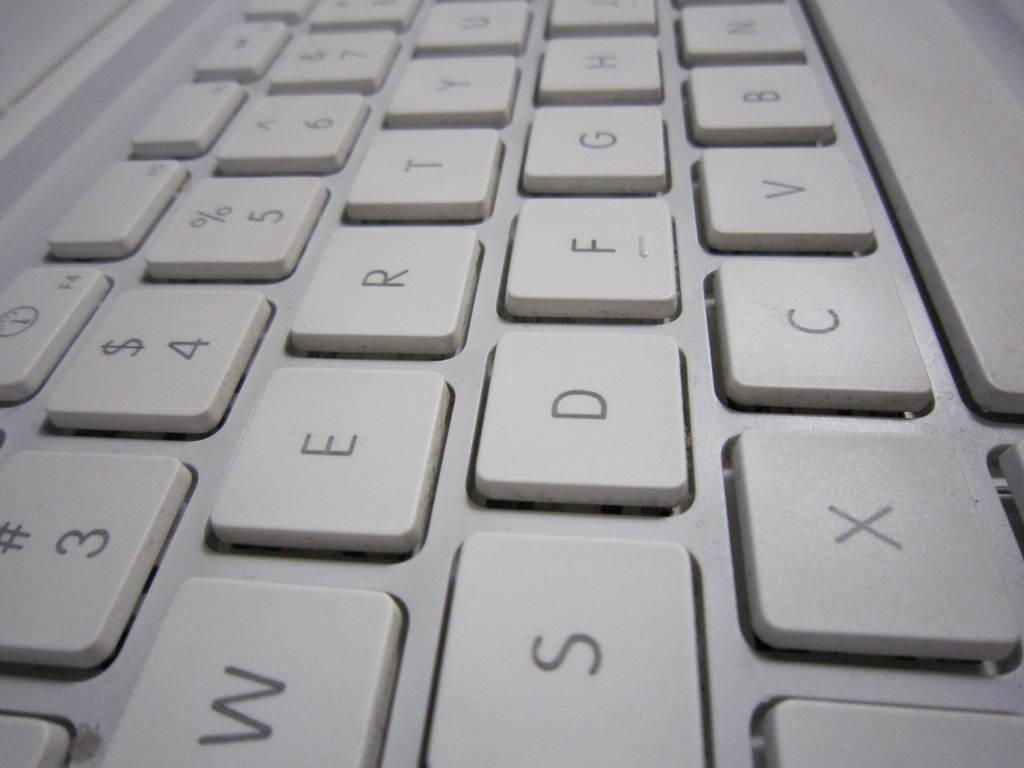Which number key is below 4?
Ensure brevity in your answer.  3. What key is to the left of the "c" key?
Provide a short and direct response. X. 